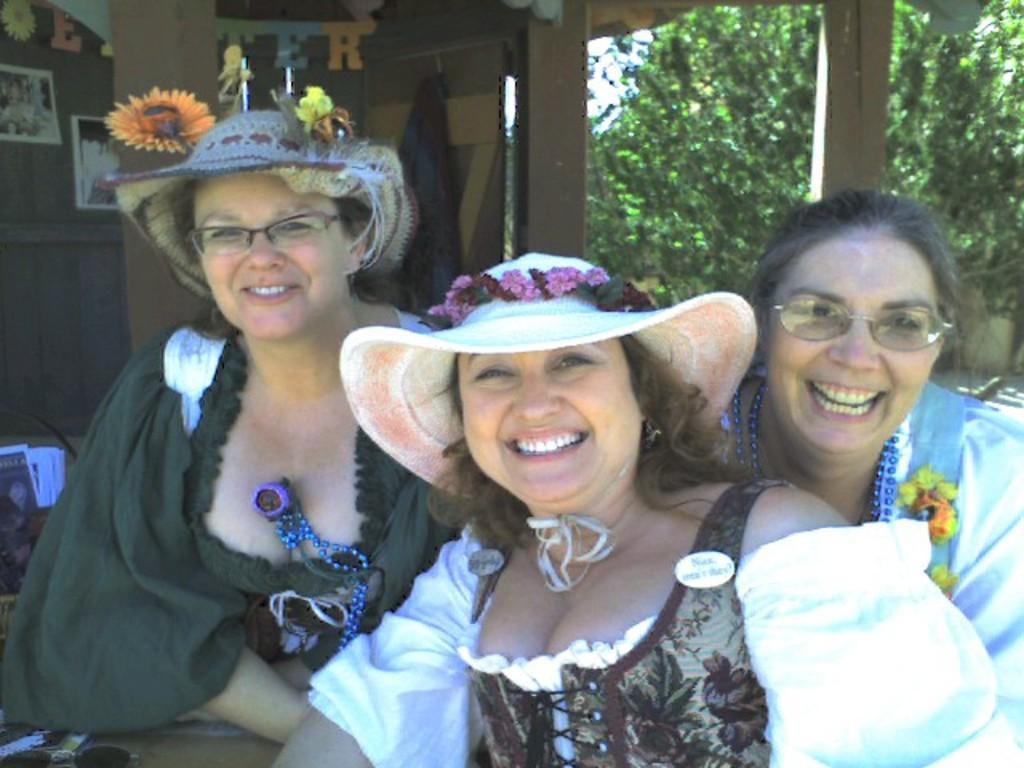Could you give a brief overview of what you see in this image? In this image I can see few people are smiling and wearing different color dresses. I can see few trees, papers and few posters and few decorative items are attached to the brown color surface. 